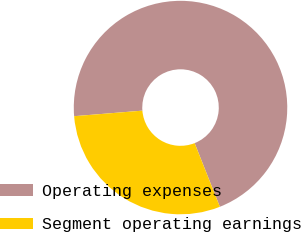<chart> <loc_0><loc_0><loc_500><loc_500><pie_chart><fcel>Operating expenses<fcel>Segment operating earnings<nl><fcel>70.28%<fcel>29.72%<nl></chart> 